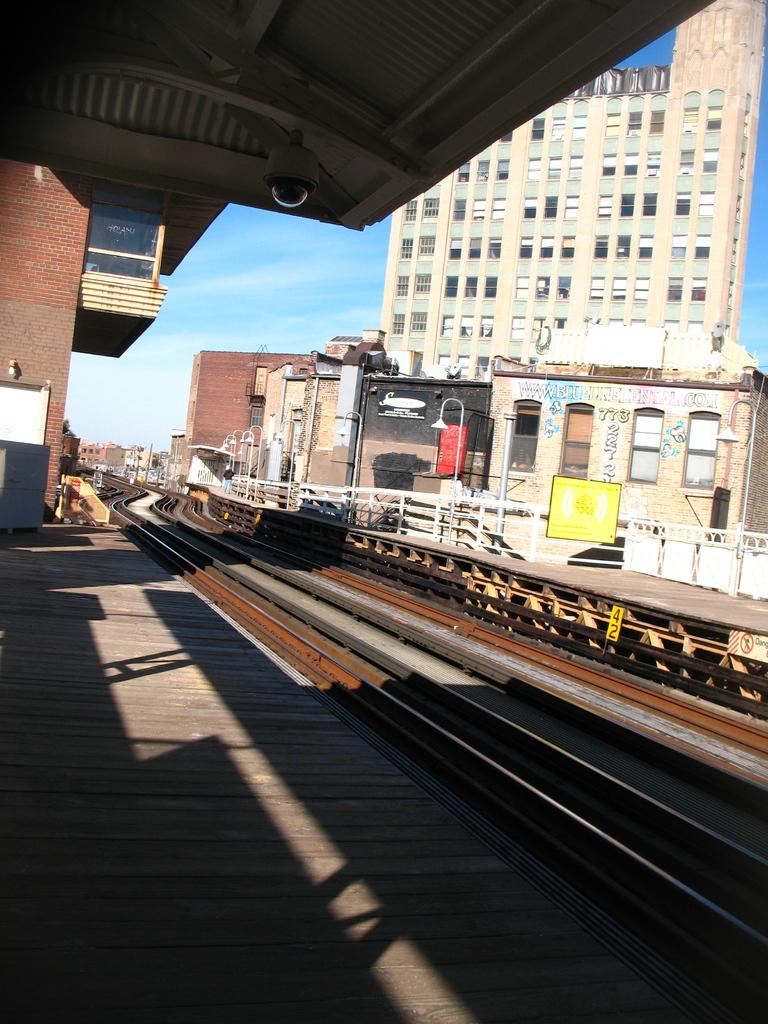What is the main subject in the center of the image? There is a railway track in the center of the image. What can be seen in the background of the image? There are buildings, poles, a fence, and the sky visible in the background of the image. What type of sidewalk is present in the image? There is no sidewalk present in the image. How does the hammer affect the shock in the image? There is no hammer or shock present in the image. 